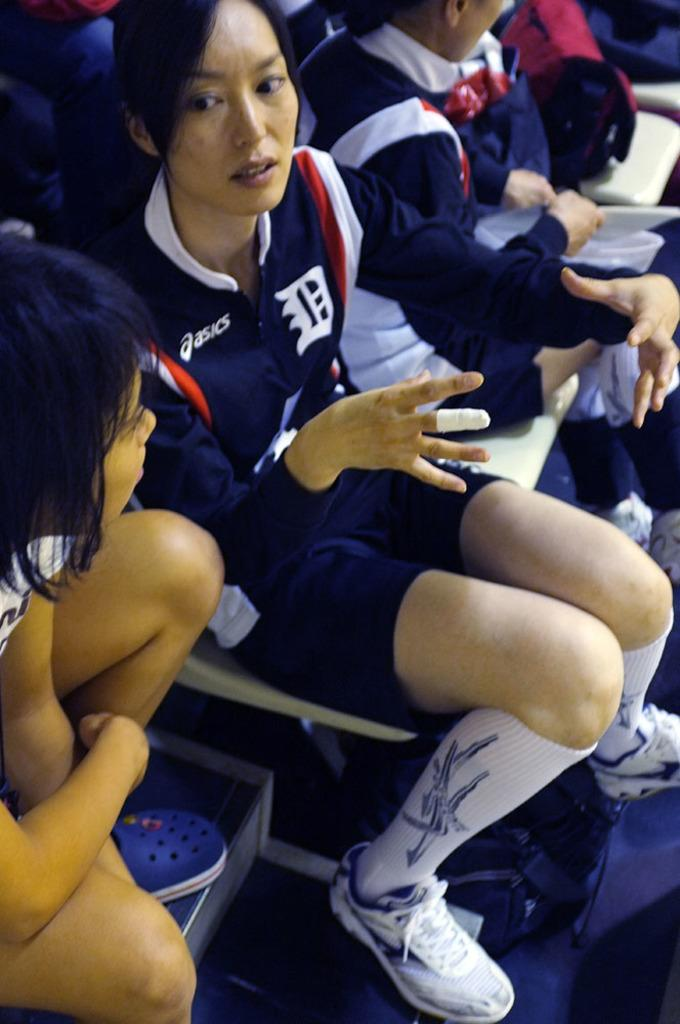Provide a one-sentence caption for the provided image. A young adult Asian woman in a sports team uniform sits on a chair among other seated young women. 